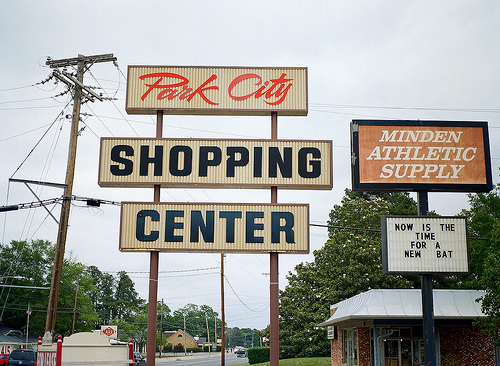<image>
Is there a sign behind the tree? No. The sign is not behind the tree. From this viewpoint, the sign appears to be positioned elsewhere in the scene. 